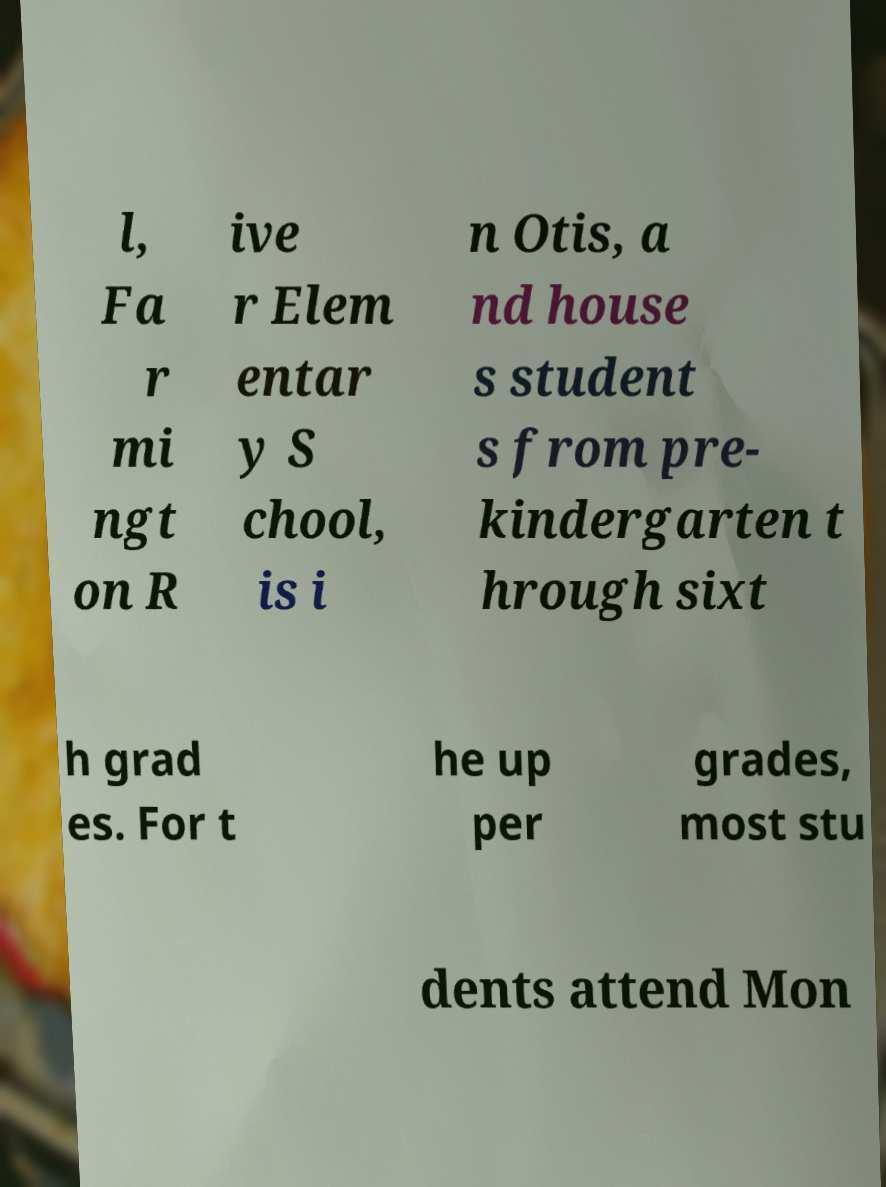Could you extract and type out the text from this image? l, Fa r mi ngt on R ive r Elem entar y S chool, is i n Otis, a nd house s student s from pre- kindergarten t hrough sixt h grad es. For t he up per grades, most stu dents attend Mon 